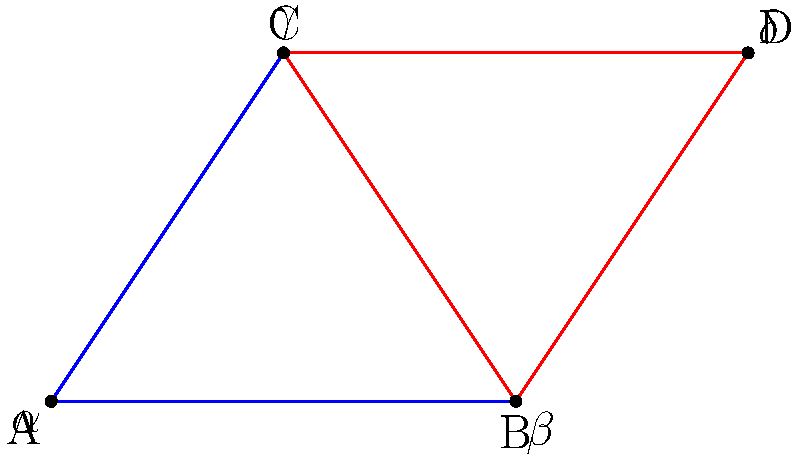In the diagram above, which represents a simplified facial symmetry analysis, two triangles are shown: ABC (blue) and BCD (red). As a dermatologist assessing facial proportions, which criterion would you use to determine if these triangles are congruent? To determine if triangles ABC and BCD are congruent, we need to apply one of the congruence criteria. Let's approach this step-by-step:

1. Observe that side BC is shared between both triangles. This is a key piece of information.

2. In facial symmetry analysis, we often look for equal angles and proportions. Here, we need to find two more corresponding parts that are equal.

3. Given that this is a simplified facial symmetry diagram, we can assume that:
   a) Angle $\alpha$ (at A) is equal to angle $\delta$ (at D), as they represent corresponding facial angles.
   b) AB = CD, as they represent equal facial distances (e.g., from eye to chin on each side).

4. Now we have:
   - One side (BC) that is common to both triangles
   - Two corresponding angles that are equal ($\alpha = \delta$)
   - Two corresponding sides that are equal (AB = CD)

5. This matches the AAS (Angle-Angle-Side) congruence criterion:
   - Two pairs of corresponding angles are equal
   - One pair of corresponding sides is equal

Therefore, we can conclude that triangles ABC and BCD are congruent based on the AAS criterion.
Answer: AAS (Angle-Angle-Side) criterion 